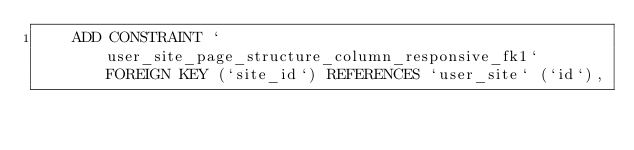Convert code to text. <code><loc_0><loc_0><loc_500><loc_500><_SQL_>    ADD CONSTRAINT `user_site_page_structure_column_responsive_fk1` FOREIGN KEY (`site_id`) REFERENCES `user_site` (`id`),</code> 